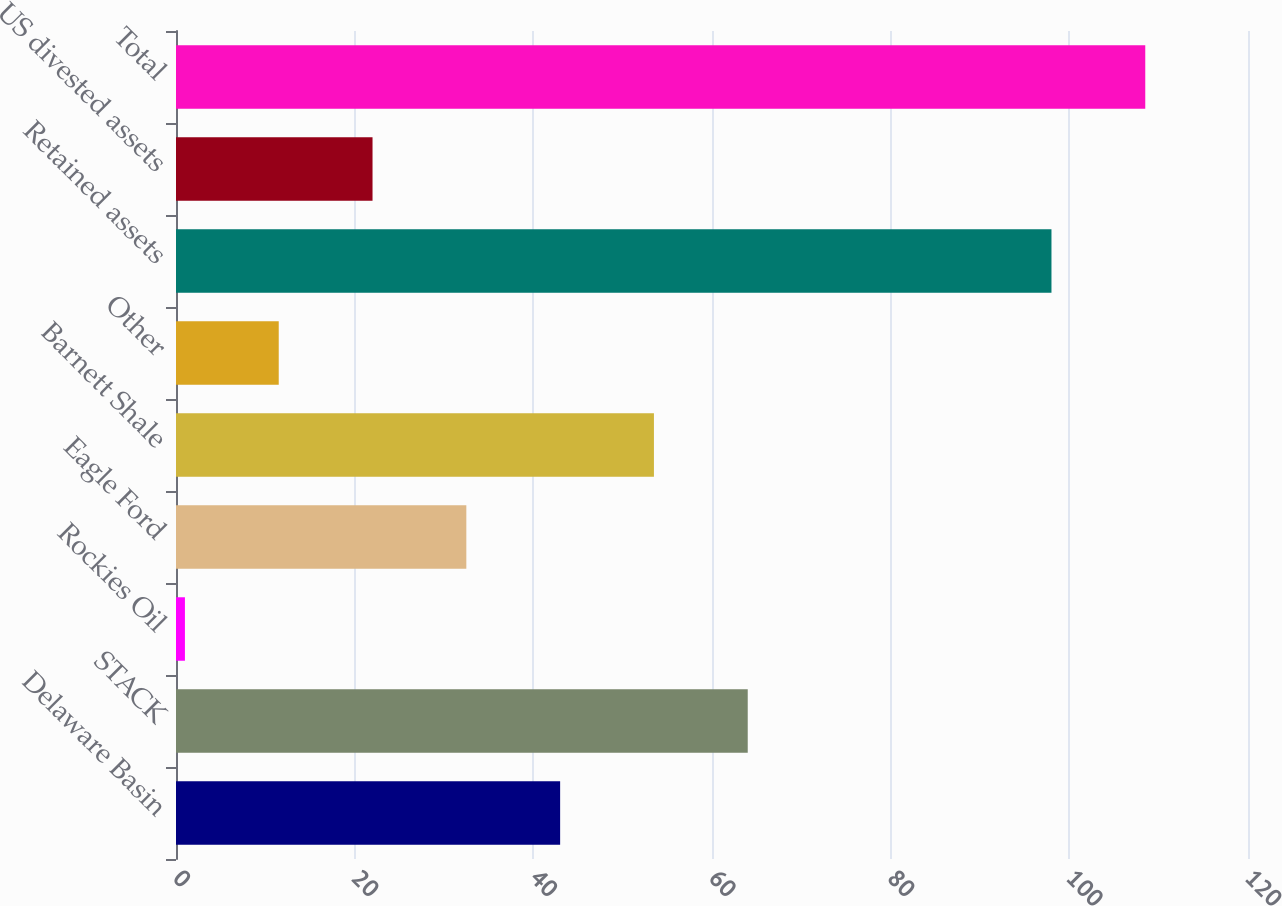Convert chart to OTSL. <chart><loc_0><loc_0><loc_500><loc_500><bar_chart><fcel>Delaware Basin<fcel>STACK<fcel>Rockies Oil<fcel>Eagle Ford<fcel>Barnett Shale<fcel>Other<fcel>Retained assets<fcel>US divested assets<fcel>Total<nl><fcel>43<fcel>64<fcel>1<fcel>32.5<fcel>53.5<fcel>11.5<fcel>98<fcel>22<fcel>108.5<nl></chart> 